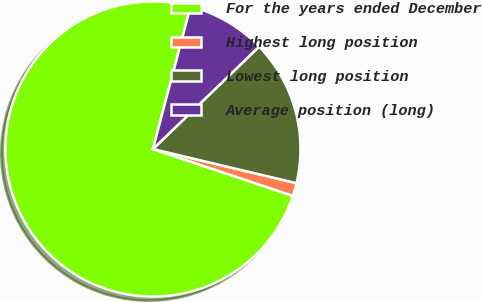Convert chart. <chart><loc_0><loc_0><loc_500><loc_500><pie_chart><fcel>For the years ended December<fcel>Highest long position<fcel>Lowest long position<fcel>Average position (long)<nl><fcel>73.97%<fcel>1.42%<fcel>15.93%<fcel>8.68%<nl></chart> 